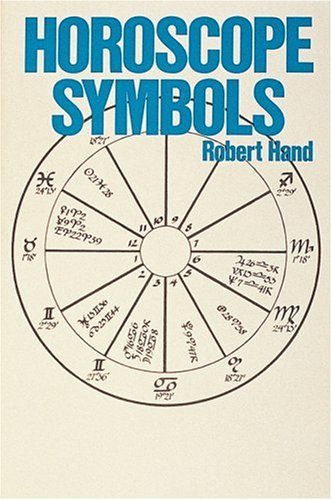Who is the author of this book? The author of 'Horoscope Symbols' is Robert Hand, an esteemed astrologer known for his comprehensive work in astrology. 